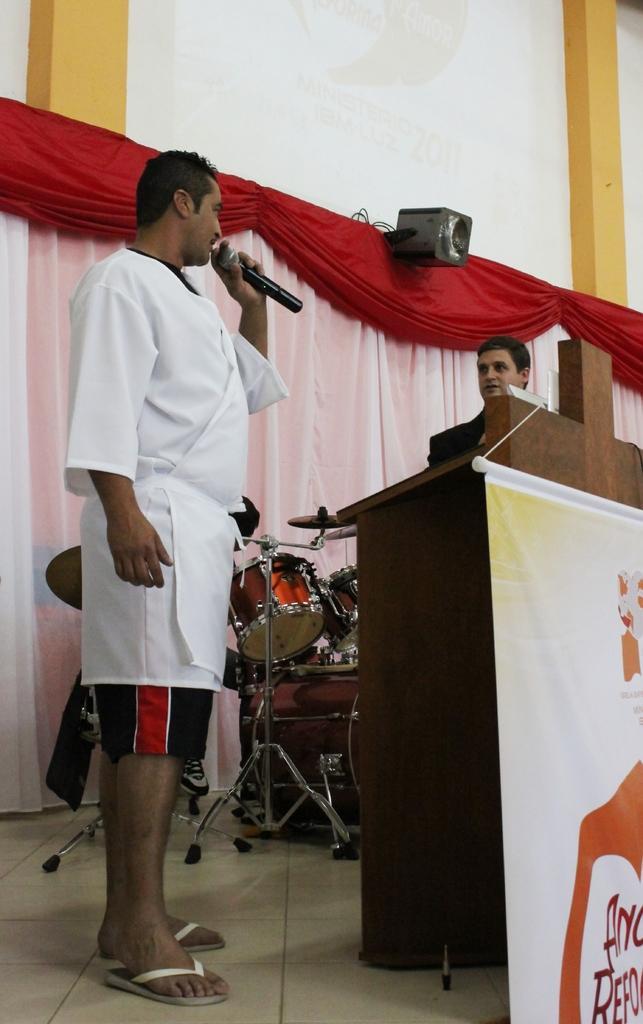Could you give a brief overview of what you see in this image? In this image we can see a man standing and holding a mic, next to him there is another man. On the right there is a podium and we can see a banner. In the background there is a band, curtains, speaker and a wall. 